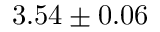Convert formula to latex. <formula><loc_0><loc_0><loc_500><loc_500>3 . 5 4 \pm 0 . 0 6</formula> 